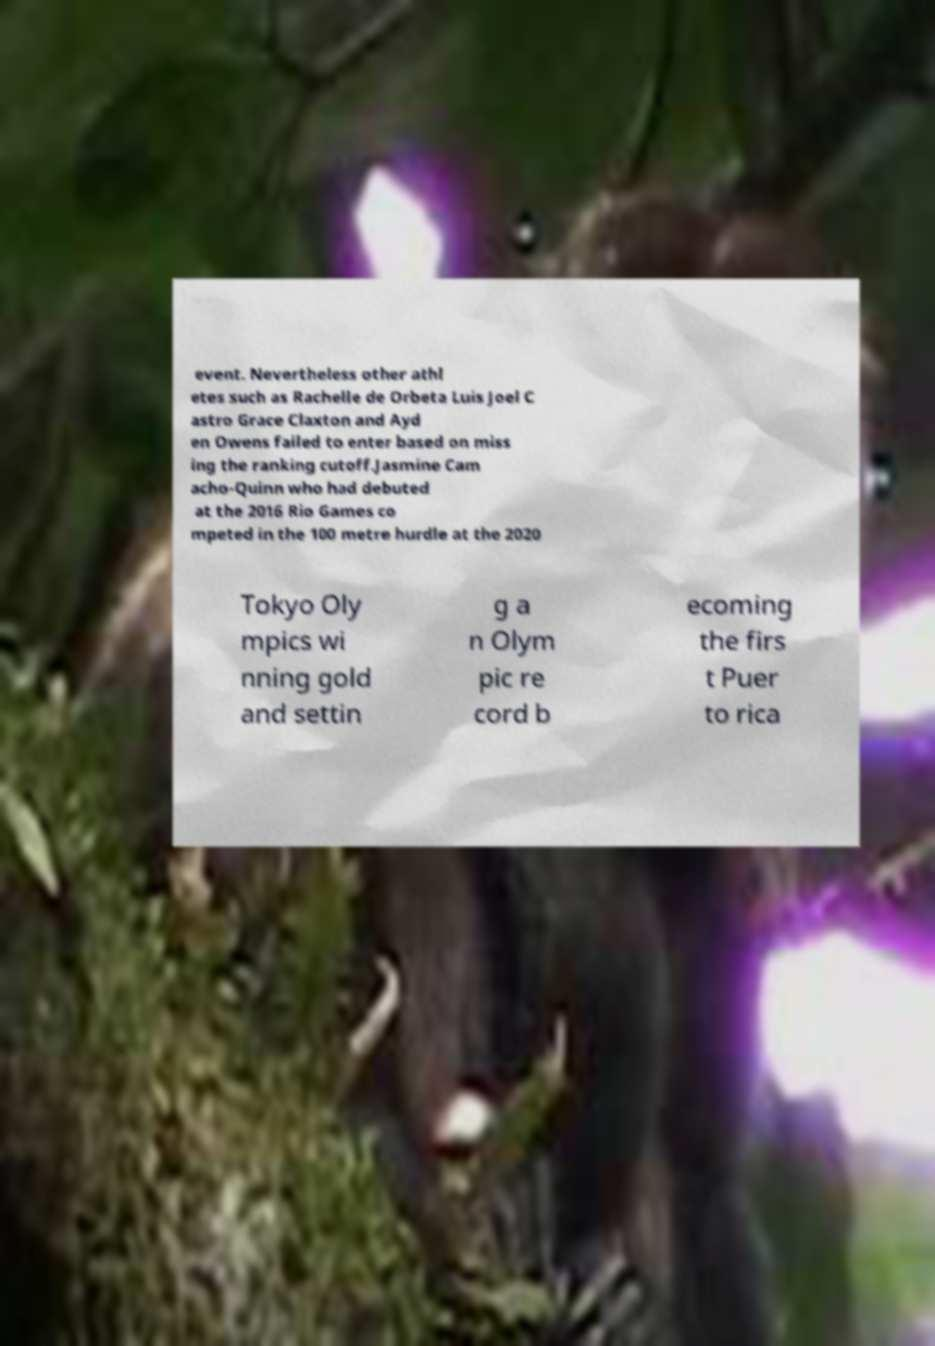Please identify and transcribe the text found in this image. event. Nevertheless other athl etes such as Rachelle de Orbeta Luis Joel C astro Grace Claxton and Ayd en Owens failed to enter based on miss ing the ranking cutoff.Jasmine Cam acho-Quinn who had debuted at the 2016 Rio Games co mpeted in the 100 metre hurdle at the 2020 Tokyo Oly mpics wi nning gold and settin g a n Olym pic re cord b ecoming the firs t Puer to rica 